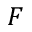Convert formula to latex. <formula><loc_0><loc_0><loc_500><loc_500>F</formula> 